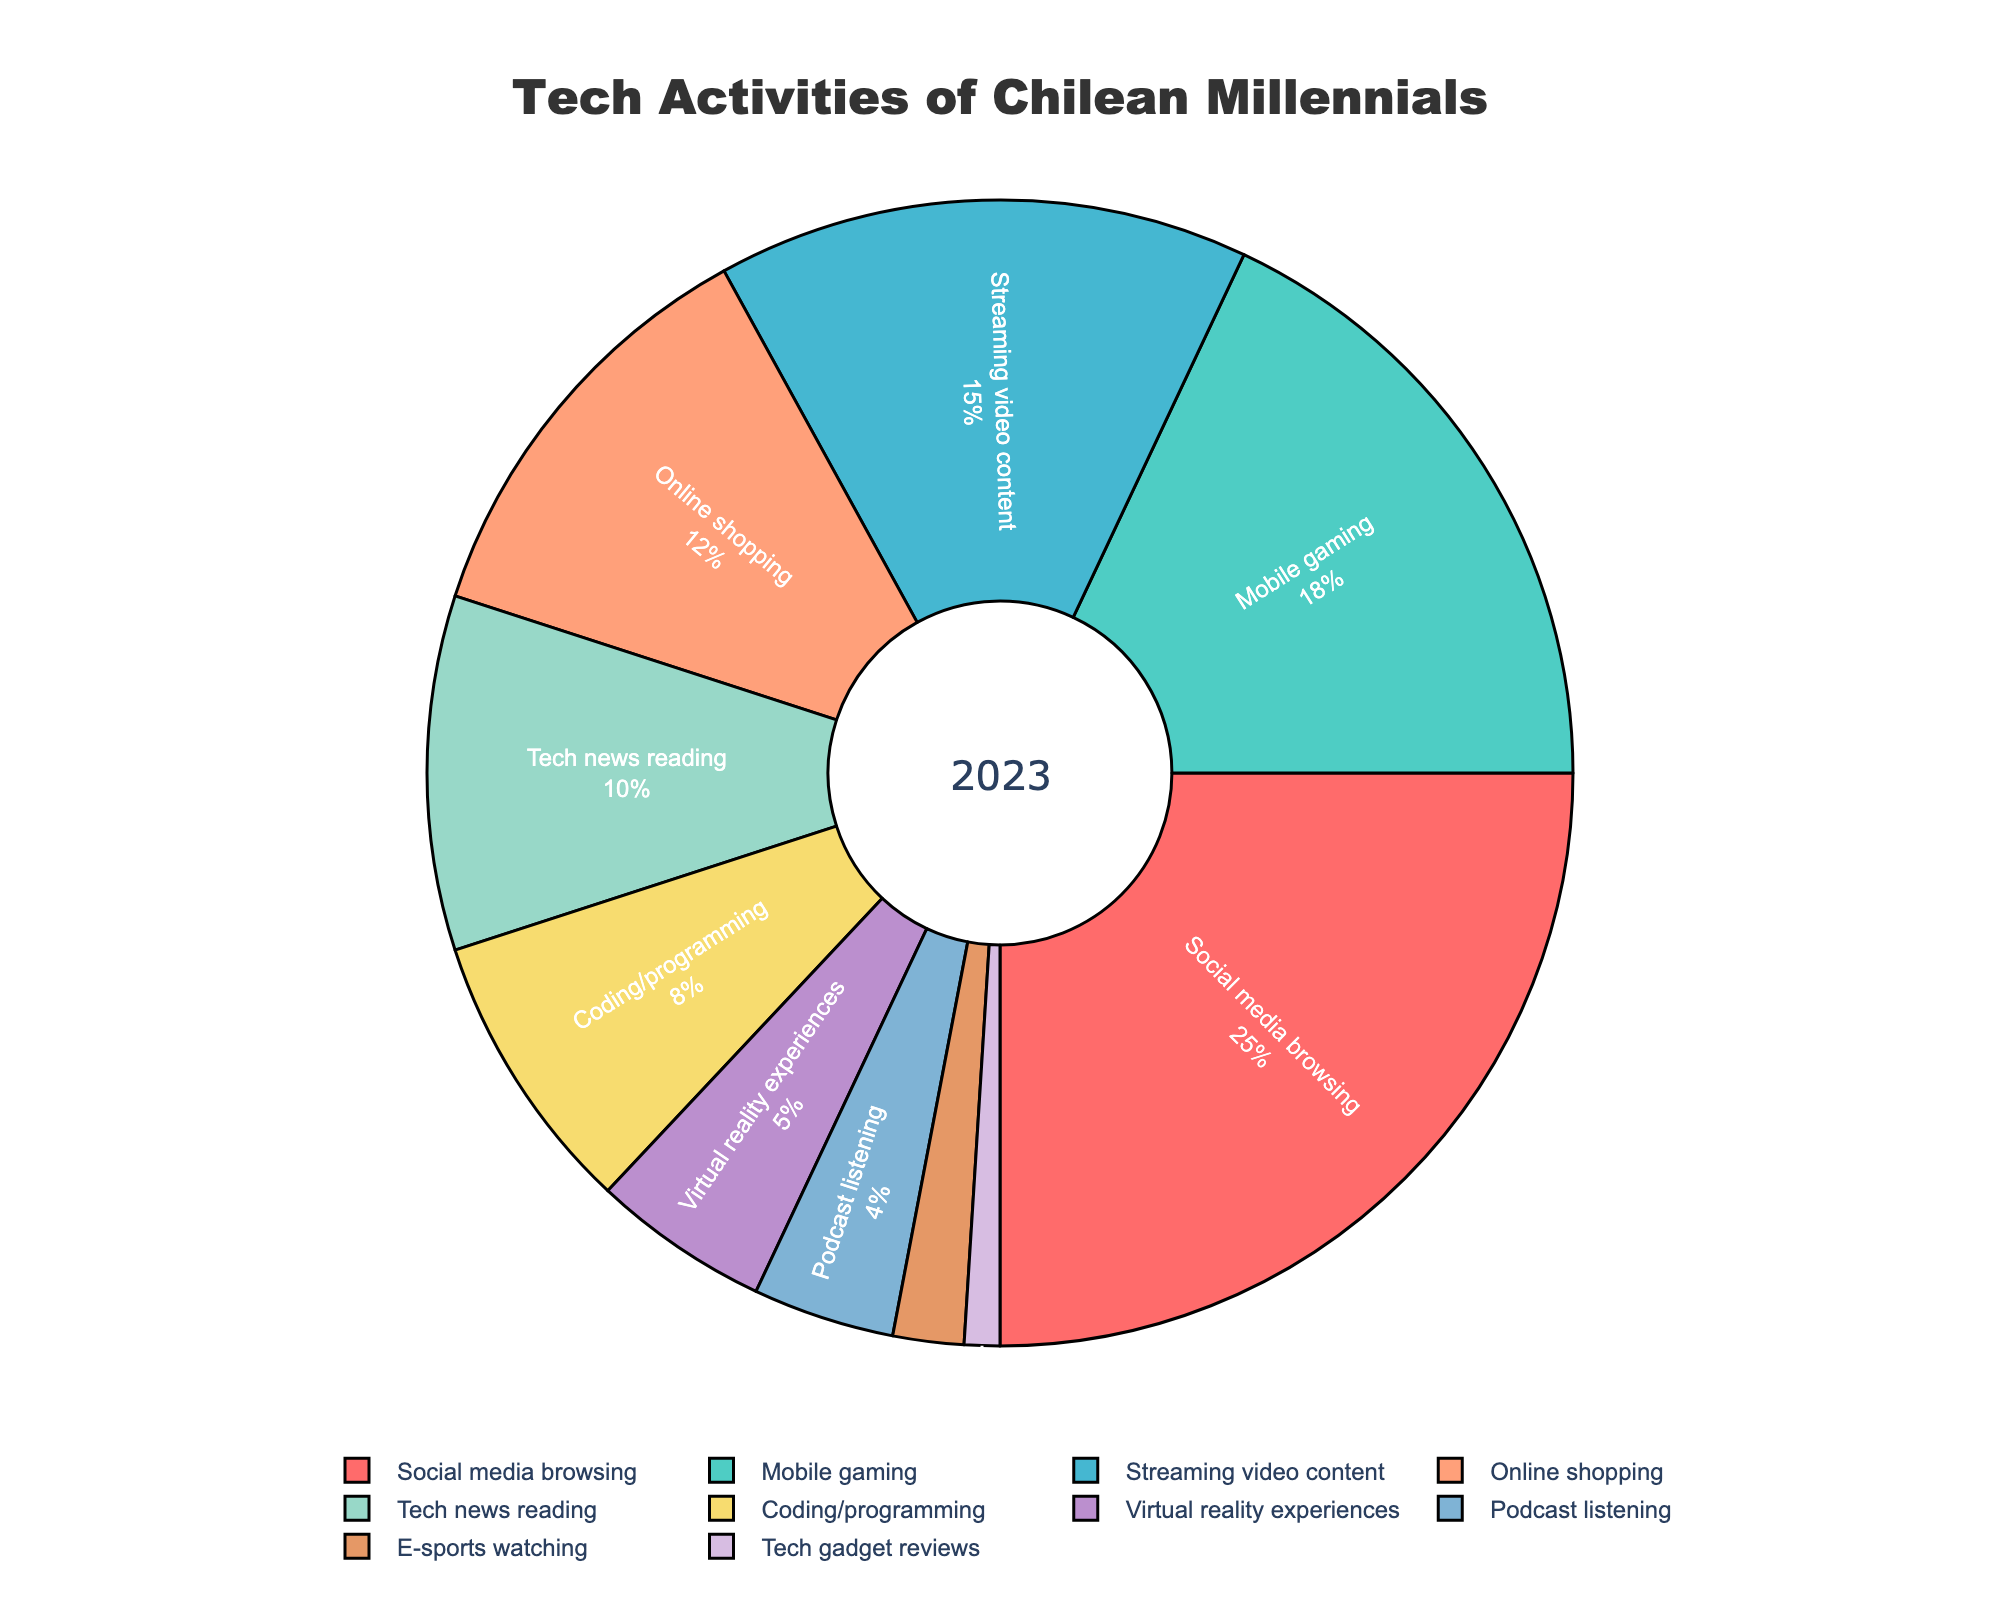What's the largest percentage allocated to a single tech activity? The largest slice of the pie chart will represent the activity with the highest percentage. By visually identifying the largest segment, which is labeled "Social media browsing", it corresponds to 25%.
Answer: 25% What's the total percentage allocated to 'Streaming video content' and 'Mobile gaming'? Locate the segments for "Streaming video content" and "Mobile gaming" in the pie chart. Their percentages are 15% and 18%, respectively. Sum these values: 15 + 18 = 33.
Answer: 33% Which tech activity is allocated twice the percentage of 'Coding/programming'? Identify the percentage for "Coding/programming", which is 8%. Then find the activity with exactly 16% (twice the percentage). No activity matches exactly, but "Mobile gaming" is closest with 18%.
Answer: Mobile gaming Is the percentage of time spent on 'Online shopping' greater than that on 'Tech gadget reviews'? Compare the percentages: "Online shopping" has 12%, while "Tech gadget reviews" has 1%. 12% is greater than 1%.
Answer: Yes Which two activities combined have a total percentage of 30? Find two segments that sum up to 30%. "Tech news reading" is 10% and "Mobile gaming" is 18%, but they sum to 28%. Let's try "Tech news reading" (10%) and "Online shopping" (12%); they sum to 22%. Now, try "Podcast listening" (4%) and "Mobile gaming" (18%); summing them gives 22%. Lastly, "Podcast listening" (4%) and "Social media browsing" (25%) sum to 29%. None seem to sum to 30%. No direct match.
Answer: No pairing What's the percentage difference between 'Virtual reality experiences' and 'E-sports watching'? Identify the percentages: "Virtual reality experiences" is 5%, and "E-sports watching" is 2%. Compute the difference: 5 - 2 = 3.
Answer: 3% Comparing 'Tech news reading' and 'Coding/programming', which has a higher percentage? Compare the slices labeled: "Tech news reading" (10%) and "Coding/programming" (8%). 10% is higher than 8%.
Answer: Tech news reading Which color corresponds to the 'Social media browsing' segment? Locate the segment labeled "Social media browsing", which is the largest. Observing the color, it is red.
Answer: Red How much more percentage is spent on 'Mobile gaming' than on 'Tech gadget reviews'? Identify the percentages: "Mobile gaming" is 18%, and "Tech gadget reviews" is 1%. Compute the difference: 18 - 1 = 17.
Answer: 17% If you sum the percentages of 'Podcast listening' and 'E-sports watching', what fraction of the total does it represent? Identify the percentages for "Podcast listening" (4%) and "E-sports watching" (2%). Their sum is 4 + 2 = 6. Since it’s out of 100, the fraction is 6/100 or 0.06 of the total.
Answer: 0.06 